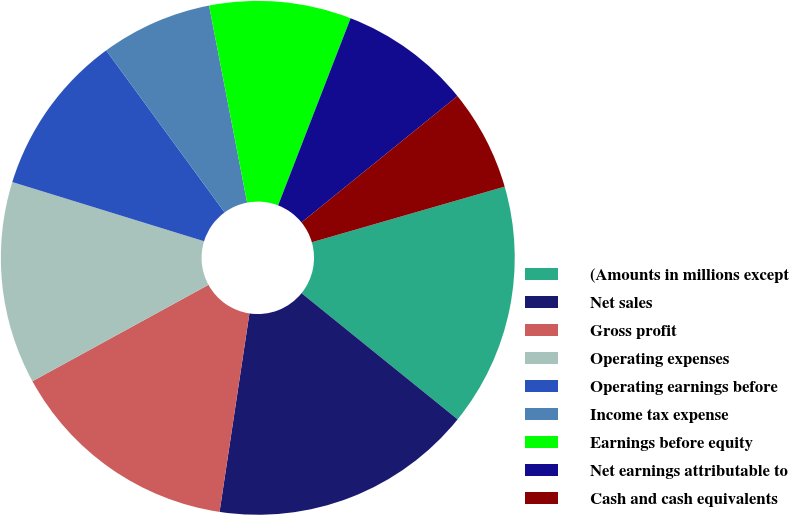Convert chart to OTSL. <chart><loc_0><loc_0><loc_500><loc_500><pie_chart><fcel>(Amounts in millions except<fcel>Net sales<fcel>Gross profit<fcel>Operating expenses<fcel>Operating earnings before<fcel>Income tax expense<fcel>Earnings before equity<fcel>Net earnings attributable to<fcel>Cash and cash equivalents<nl><fcel>15.29%<fcel>16.56%<fcel>14.65%<fcel>12.74%<fcel>10.19%<fcel>7.01%<fcel>8.92%<fcel>8.28%<fcel>6.37%<nl></chart> 